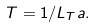<formula> <loc_0><loc_0><loc_500><loc_500>T = 1 / L _ { T } a .</formula> 